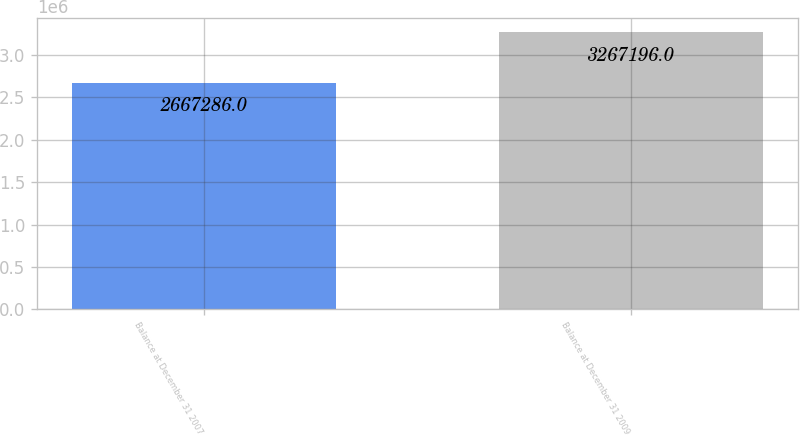Convert chart to OTSL. <chart><loc_0><loc_0><loc_500><loc_500><bar_chart><fcel>Balance at December 31 2007<fcel>Balance at December 31 2009<nl><fcel>2.66729e+06<fcel>3.2672e+06<nl></chart> 